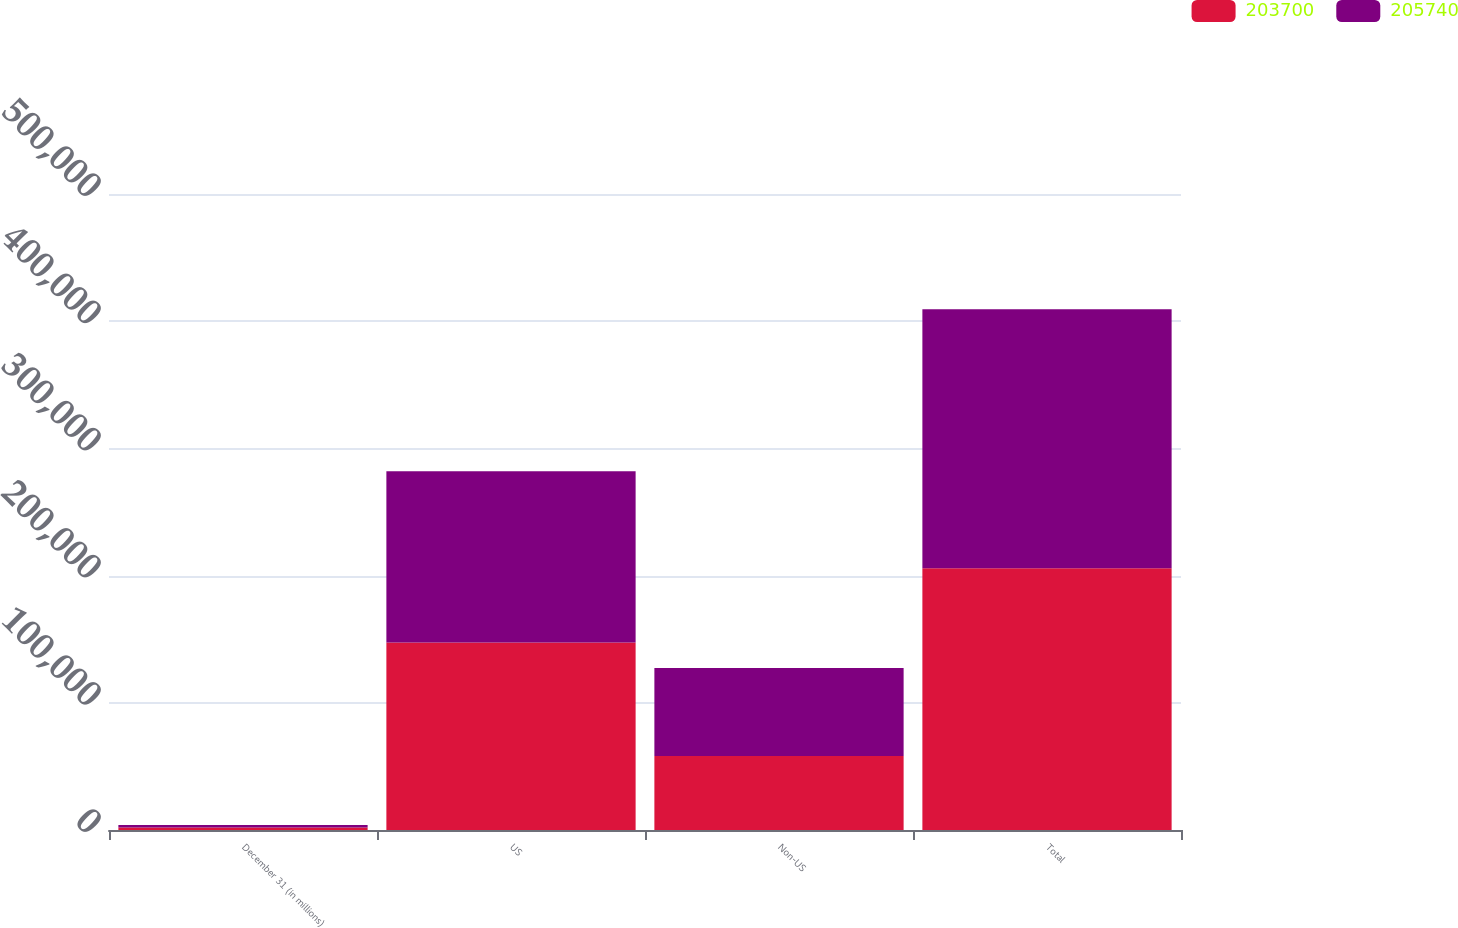Convert chart. <chart><loc_0><loc_0><loc_500><loc_500><stacked_bar_chart><ecel><fcel>December 31 (in millions)<fcel>US<fcel>Non-US<fcel>Total<nl><fcel>203700<fcel>2008<fcel>147493<fcel>58247<fcel>205740<nl><fcel>205740<fcel>2007<fcel>134529<fcel>69171<fcel>203700<nl></chart> 